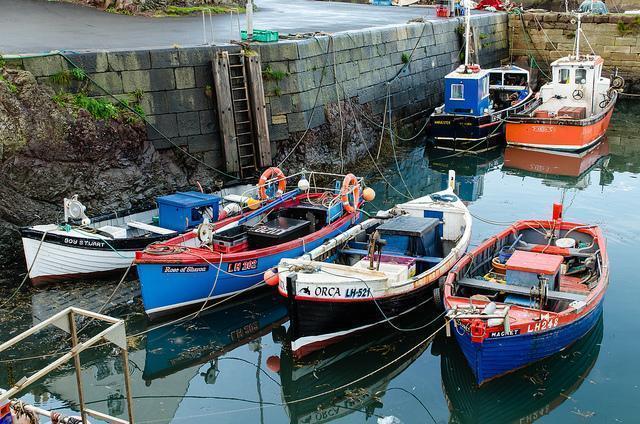What is available to get from the boats to the ground level?
Make your selection from the four choices given to correctly answer the question.
Options: Rope, stairs, ladder, elevator. Ladder. 